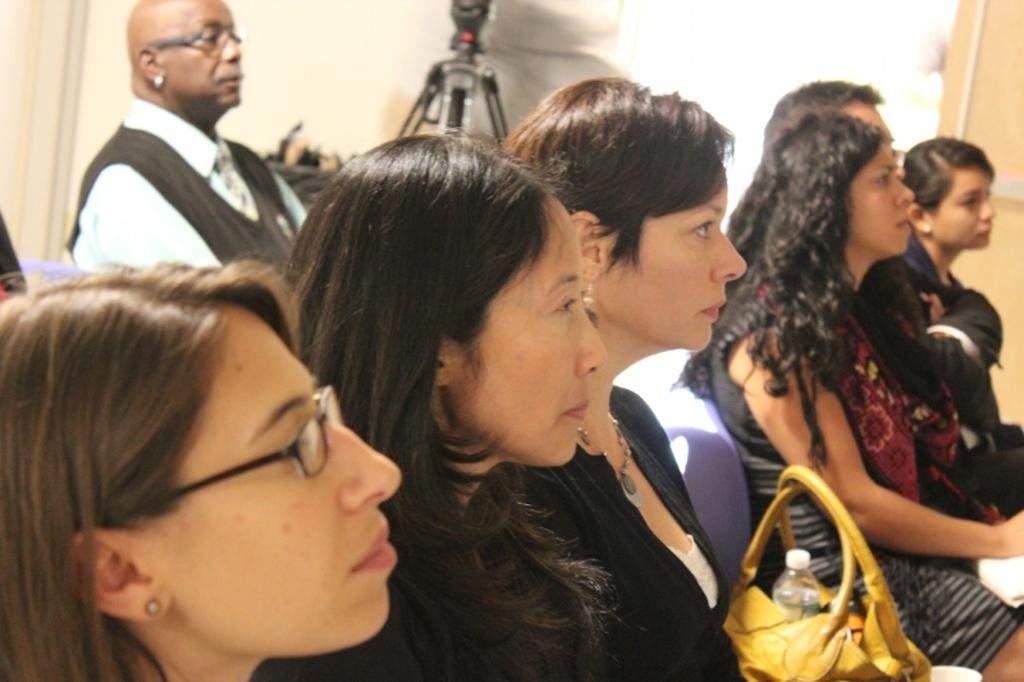What is the primary subject of the image? The primary subject of the image is a group of people sitting on chairs. Can you describe the people in the image? There are ladies sitting on chairs in the front of the image, and a man is sitting in the back of the image. What object can be seen in front of the wall in the image? There is a tripod in front of the wall in the image. How does the wind affect the man's quiver in the image? There is no wind or quiver present in the image; it features a group of people sitting on chairs and a tripod. 